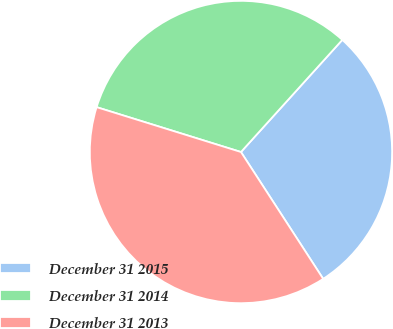Convert chart. <chart><loc_0><loc_0><loc_500><loc_500><pie_chart><fcel>December 31 2015<fcel>December 31 2014<fcel>December 31 2013<nl><fcel>29.15%<fcel>31.9%<fcel>38.95%<nl></chart> 